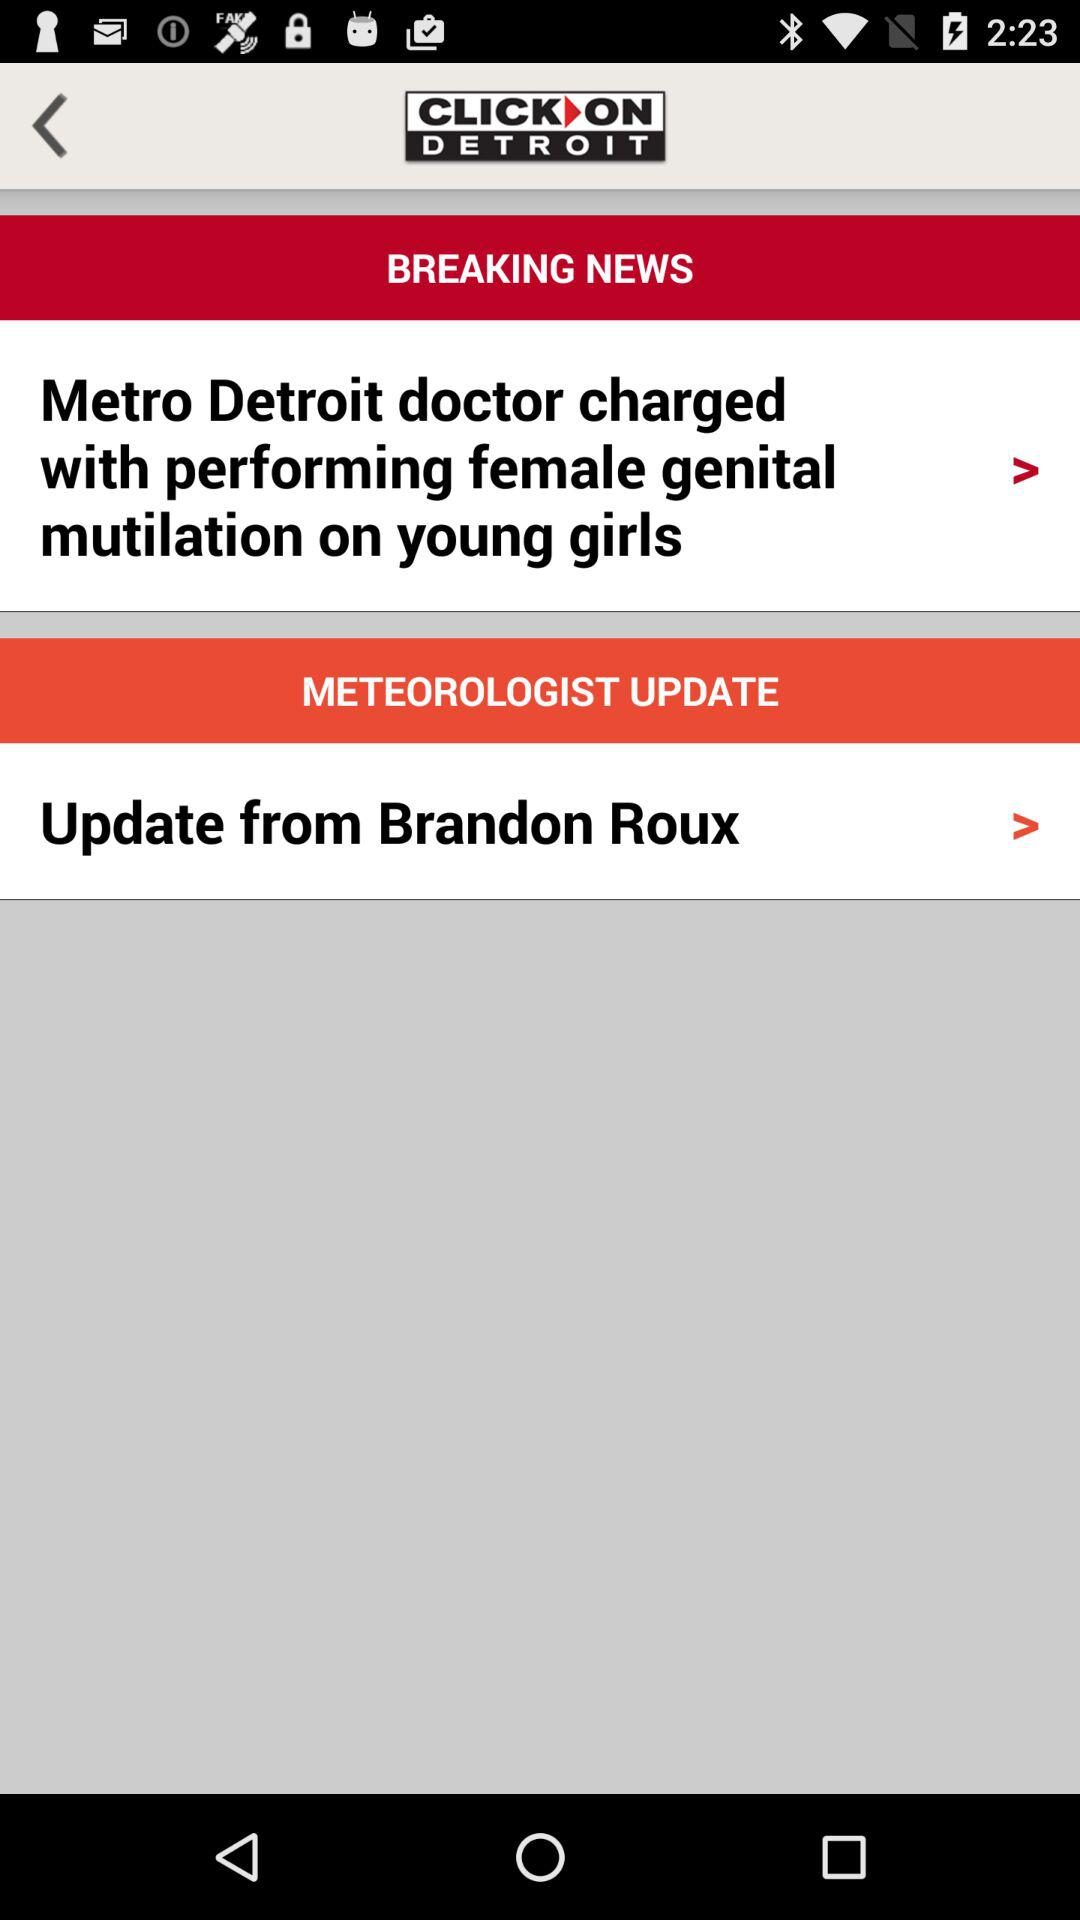What is the application name? The application name is "CLICK ON DETROIT". 